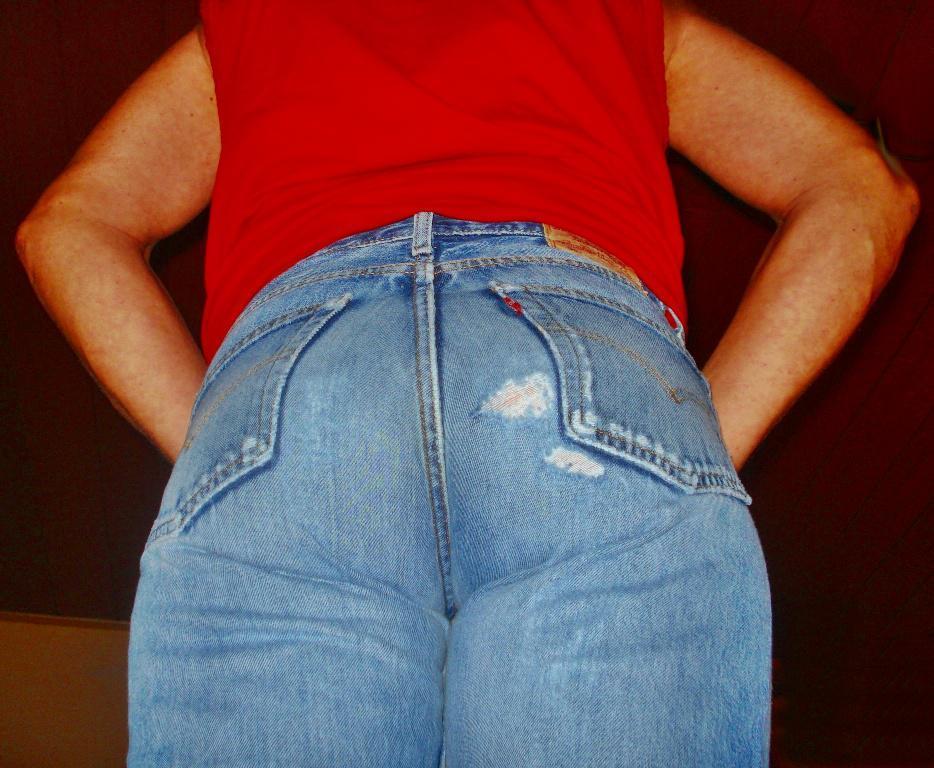In one or two sentences, can you explain what this image depicts? There is a person wore jean and red t shirt. In the background it is dark. 